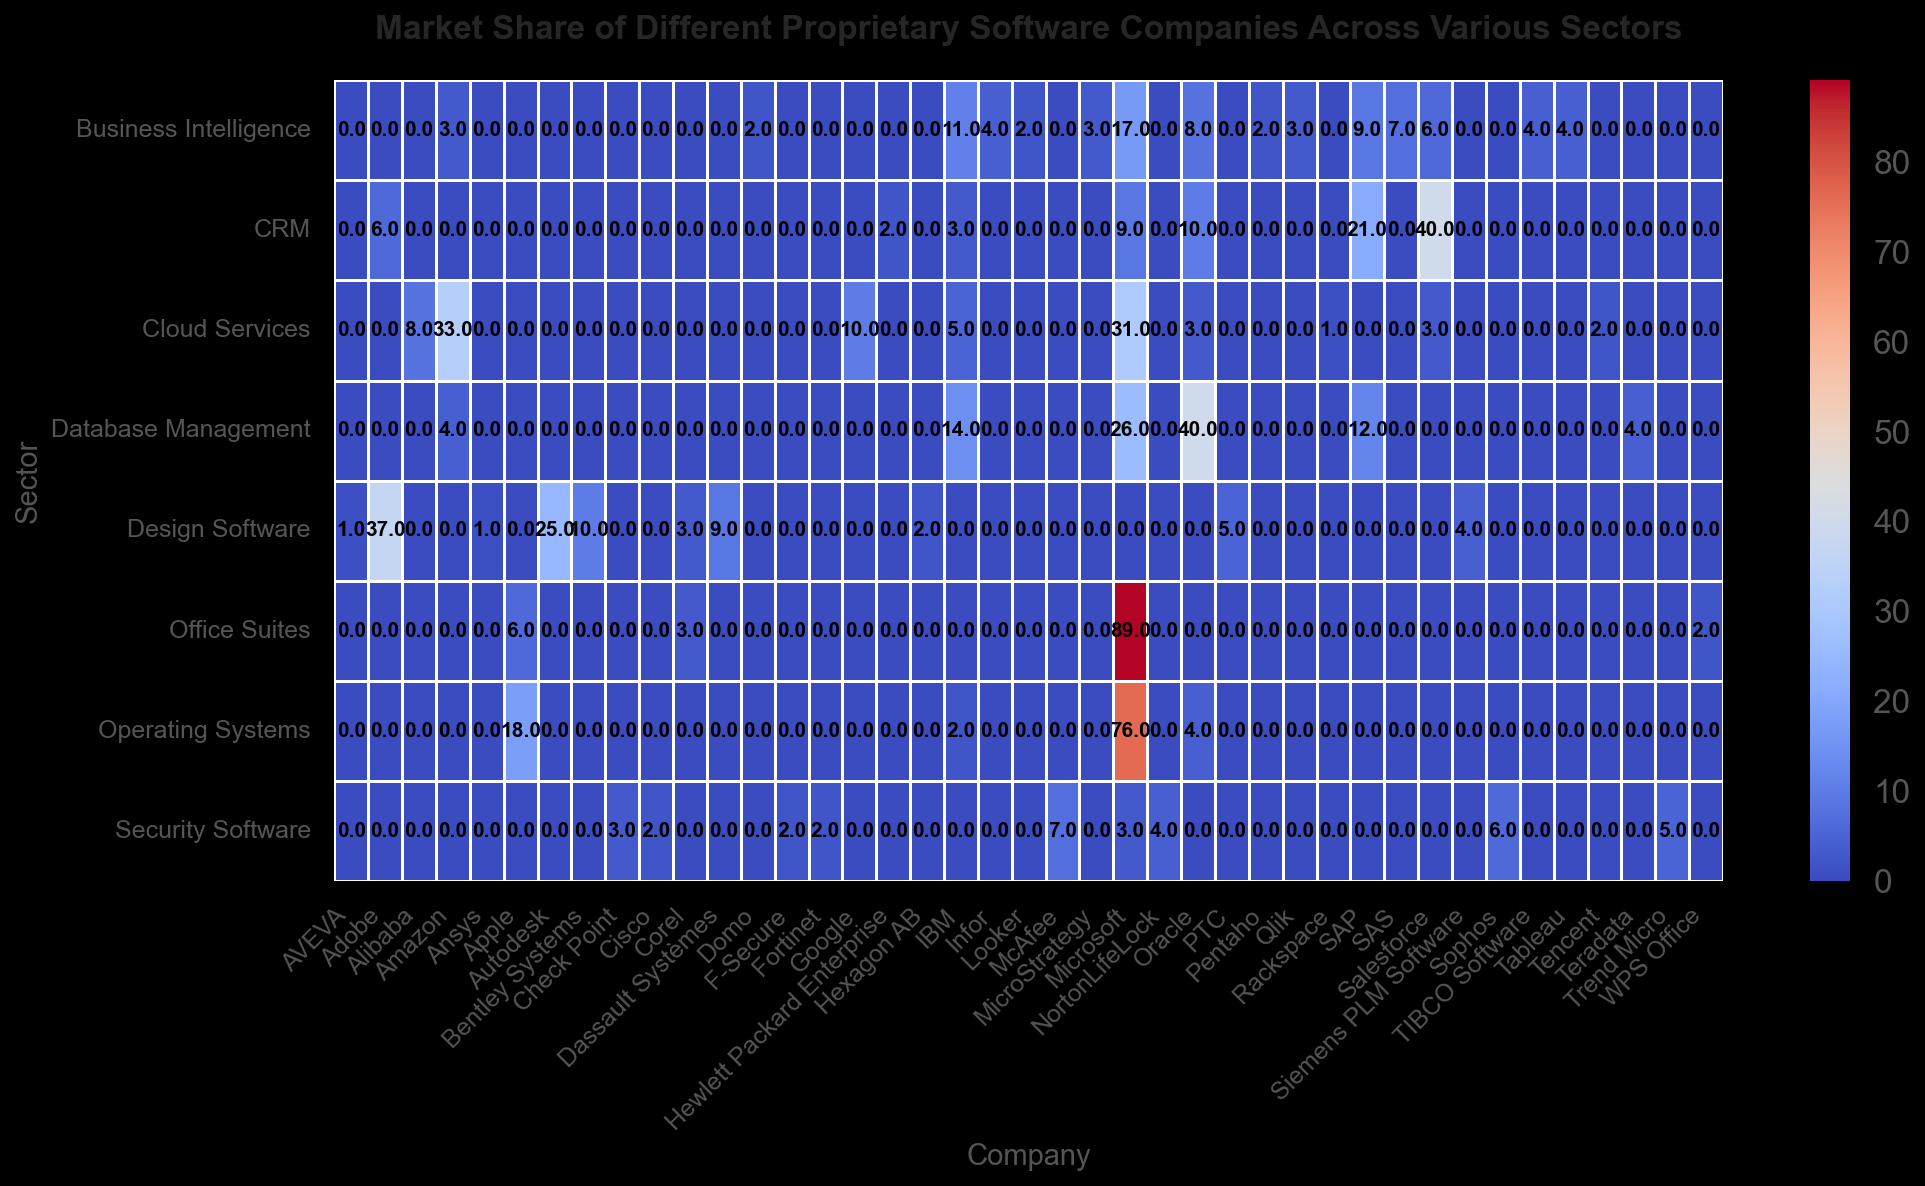What sector does Microsoft have the highest market share in? To answer this question, locate all the sectors where Microsoft appears and check the values. The highest value will show the sector where the market share is highest.
Answer: Office Suites Which sector has the most balanced market share among the companies listed? "Balanced" market share implies that no single company dominates the sector. Examine the sectors and check the spread of values for each company. "Database Management" stands out because its market shares are relatively distributed among several companies.
Answer: Database Management How does the market share of Salesforce in the CRM sector compare to its market share in the Cloud Services sector? Compare the value of Salesforce in the CRM sector with its value in the Cloud Services sector. In CRM, Salesforce has a 40% market share, and in Cloud Services, it has a 3% market share.
Answer: CRM: 40%, Cloud Services: 3% What is the combined market share of AWS and Microsoft in the Cloud Services sector? To find the combined market share, add the market share percentages of AWS and Microsoft in the Cloud Services sector. AWS has 33%, and Microsoft has 31%. So, 33% + 31% = 64%.
Answer: 64% Which company appears most frequently across different sectors in the heatmap? Count the occurrences of each company name in the different sectors. Microsoft appears in multiple sectors like Operating Systems, Office Suites, Database Management, CRM, Cloud Services, Security Software, and Business Intelligence.
Answer: Microsoft What visual pattern stands out in sectors where one company has an overwhelmingly high market share? Look for sectors where a single company has a significantly higher market share than others. This pattern is notable in Office Suites where Microsoft dominates with an 89% market share.
Answer: Dominance of one company In which sector does IBM share the closest market share with Microsoft? Compare the market shares of IBM and Microsoft across various sectors. In the Database Management sector, IBM has 14% and Microsoft has 26%, making the difference smaller compared to other sectors.
Answer: Database Management What is the average market share of Oracle across all sectors it operates in? To find the average, sum Oracle's market shares in all sectors and divide by the number of sectors. Oracle's shares are 4% (Operating Systems), 40% (Database Management), 10% (CRM), 8% (Business Intelligence), and 3% (Cloud Services). (4 + 40 + 10 + 8 + 3) / 5 = 13%.
Answer: 13% Which sector has the widest range of market shares among the companies? Calculate the range (difference between maximum and minimum values) for each sector. The sector with the highest difference indicates the widest range. It is evident in the Office Suites, where the range is 89% (Microsoft) - 2% (WPS Office) = 87%.
Answer: Office Suites Which sector has the most companies sharing market share values that are all single digits? Look for sectors where all companies have market share values under 10%. The Security Software sector has the highest presence of companies with shares in the single-digit range.
Answer: Security Software 